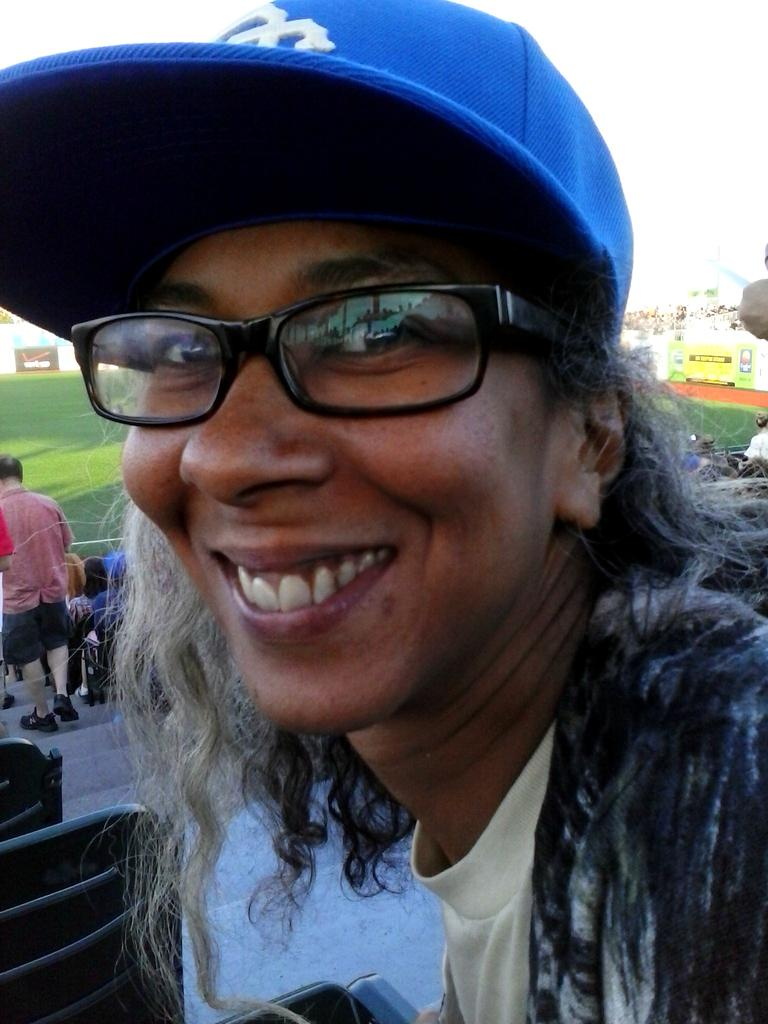What is the person in the image wearing? The person in the image is wearing a dress, specs, and a cap. Can you describe the surroundings of the person? There are other people in the background of the image, and the ground is visible. What can be seen in the distance in the image? There are broads (possibly referring to trees or buildings) in the background of the image. What is the color of the background in the image? The background of the image appears to be white. What type of knowledge is the person in the image trying to convey with their mouth? There is no indication in the image that the person is trying to convey any knowledge, and their mouth is not visible in the image. 